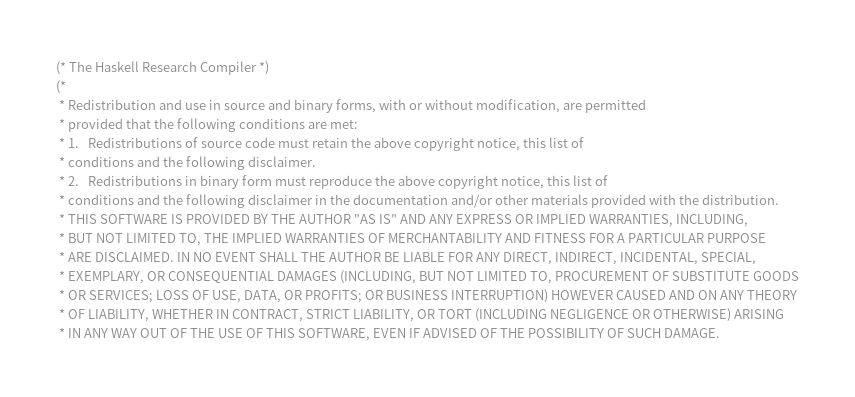Convert code to text. <code><loc_0><loc_0><loc_500><loc_500><_SML_>(* The Haskell Research Compiler *)
(*
 * Redistribution and use in source and binary forms, with or without modification, are permitted 
 * provided that the following conditions are met:
 * 1.   Redistributions of source code must retain the above copyright notice, this list of 
 * conditions and the following disclaimer.
 * 2.   Redistributions in binary form must reproduce the above copyright notice, this list of
 * conditions and the following disclaimer in the documentation and/or other materials provided with the distribution.
 * THIS SOFTWARE IS PROVIDED BY THE AUTHOR "AS IS" AND ANY EXPRESS OR IMPLIED WARRANTIES, INCLUDING,
 * BUT NOT LIMITED TO, THE IMPLIED WARRANTIES OF MERCHANTABILITY AND FITNESS FOR A PARTICULAR PURPOSE
 * ARE DISCLAIMED. IN NO EVENT SHALL THE AUTHOR BE LIABLE FOR ANY DIRECT, INDIRECT, INCIDENTAL, SPECIAL,
 * EXEMPLARY, OR CONSEQUENTIAL DAMAGES (INCLUDING, BUT NOT LIMITED TO, PROCUREMENT OF SUBSTITUTE GOODS
 * OR SERVICES; LOSS OF USE, DATA, OR PROFITS; OR BUSINESS INTERRUPTION) HOWEVER CAUSED AND ON ANY THEORY
 * OF LIABILITY, WHETHER IN CONTRACT, STRICT LIABILITY, OR TORT (INCLUDING NEGLIGENCE OR OTHERWISE) ARISING
 * IN ANY WAY OUT OF THE USE OF THIS SOFTWARE, EVEN IF ADVISED OF THE POSSIBILITY OF SUCH DAMAGE.</code> 